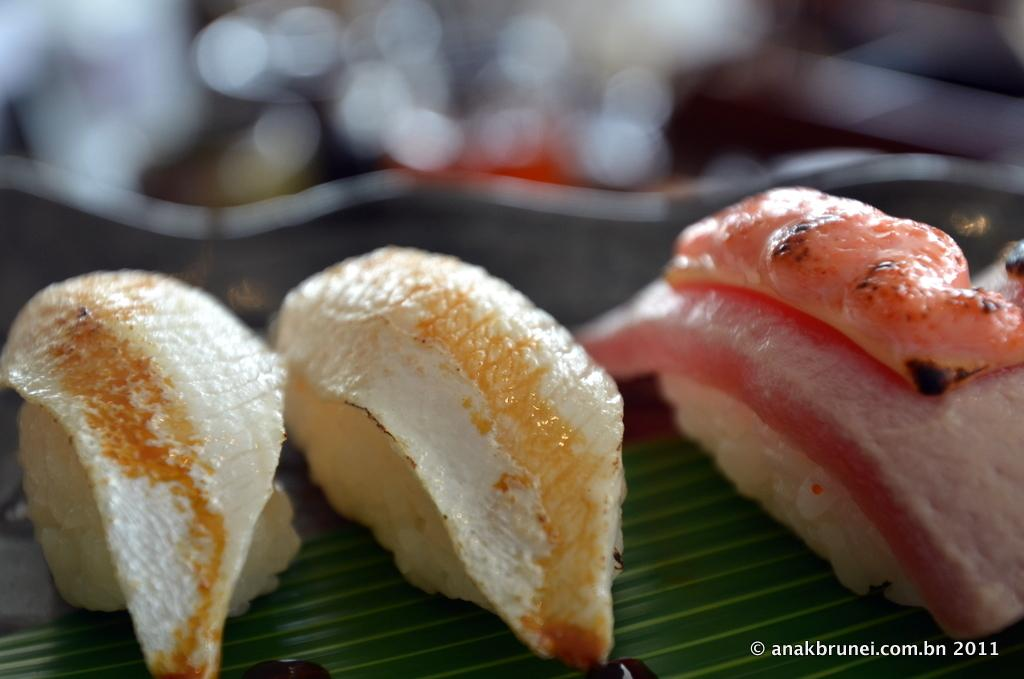What is the main subject of the image? The main subject of the image is food on a leaf. Can you describe the background of the image? The background of the image is blurry. How many examples of the design can be seen in the image? There is no design present in the image, as it features food on a leaf with a blurry background. 